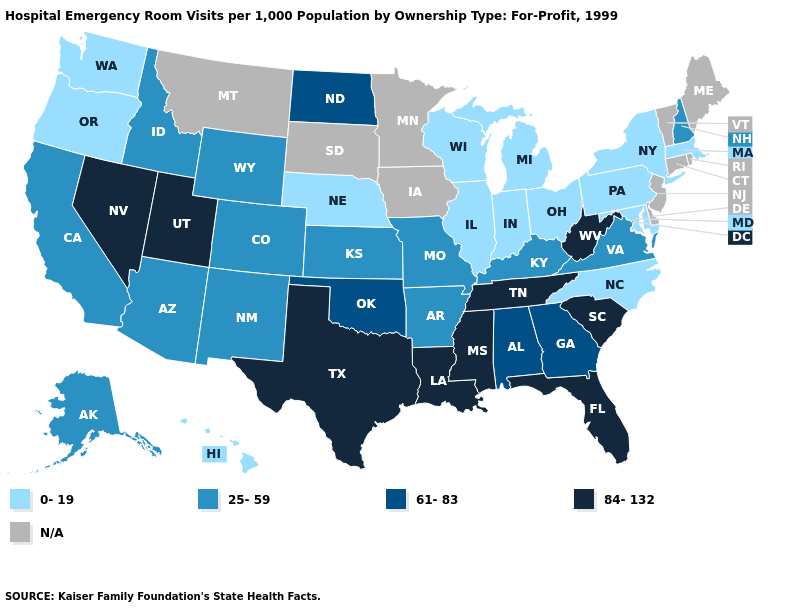Name the states that have a value in the range 0-19?
Concise answer only. Hawaii, Illinois, Indiana, Maryland, Massachusetts, Michigan, Nebraska, New York, North Carolina, Ohio, Oregon, Pennsylvania, Washington, Wisconsin. Name the states that have a value in the range 84-132?
Answer briefly. Florida, Louisiana, Mississippi, Nevada, South Carolina, Tennessee, Texas, Utah, West Virginia. Name the states that have a value in the range 25-59?
Short answer required. Alaska, Arizona, Arkansas, California, Colorado, Idaho, Kansas, Kentucky, Missouri, New Hampshire, New Mexico, Virginia, Wyoming. Does the map have missing data?
Concise answer only. Yes. Which states have the highest value in the USA?
Give a very brief answer. Florida, Louisiana, Mississippi, Nevada, South Carolina, Tennessee, Texas, Utah, West Virginia. Which states have the lowest value in the USA?
Quick response, please. Hawaii, Illinois, Indiana, Maryland, Massachusetts, Michigan, Nebraska, New York, North Carolina, Ohio, Oregon, Pennsylvania, Washington, Wisconsin. What is the lowest value in the USA?
Answer briefly. 0-19. Among the states that border Maryland , does Virginia have the highest value?
Answer briefly. No. Among the states that border Tennessee , does Mississippi have the lowest value?
Quick response, please. No. Does the map have missing data?
Quick response, please. Yes. Among the states that border Vermont , which have the lowest value?
Give a very brief answer. Massachusetts, New York. Name the states that have a value in the range 61-83?
Answer briefly. Alabama, Georgia, North Dakota, Oklahoma. What is the value of Illinois?
Concise answer only. 0-19. 